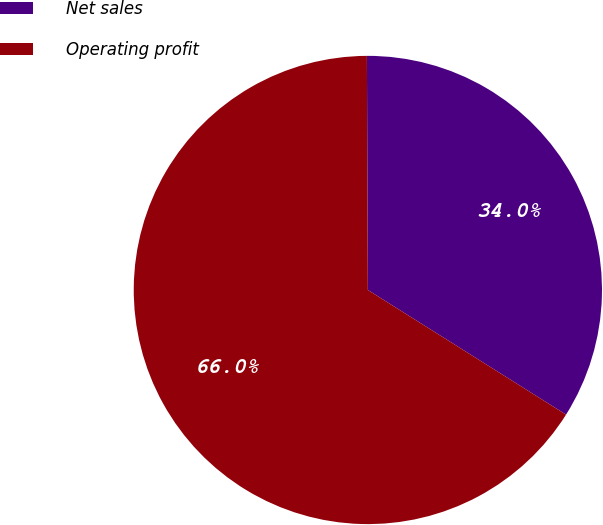Convert chart. <chart><loc_0><loc_0><loc_500><loc_500><pie_chart><fcel>Net sales<fcel>Operating profit<nl><fcel>34.0%<fcel>66.0%<nl></chart> 